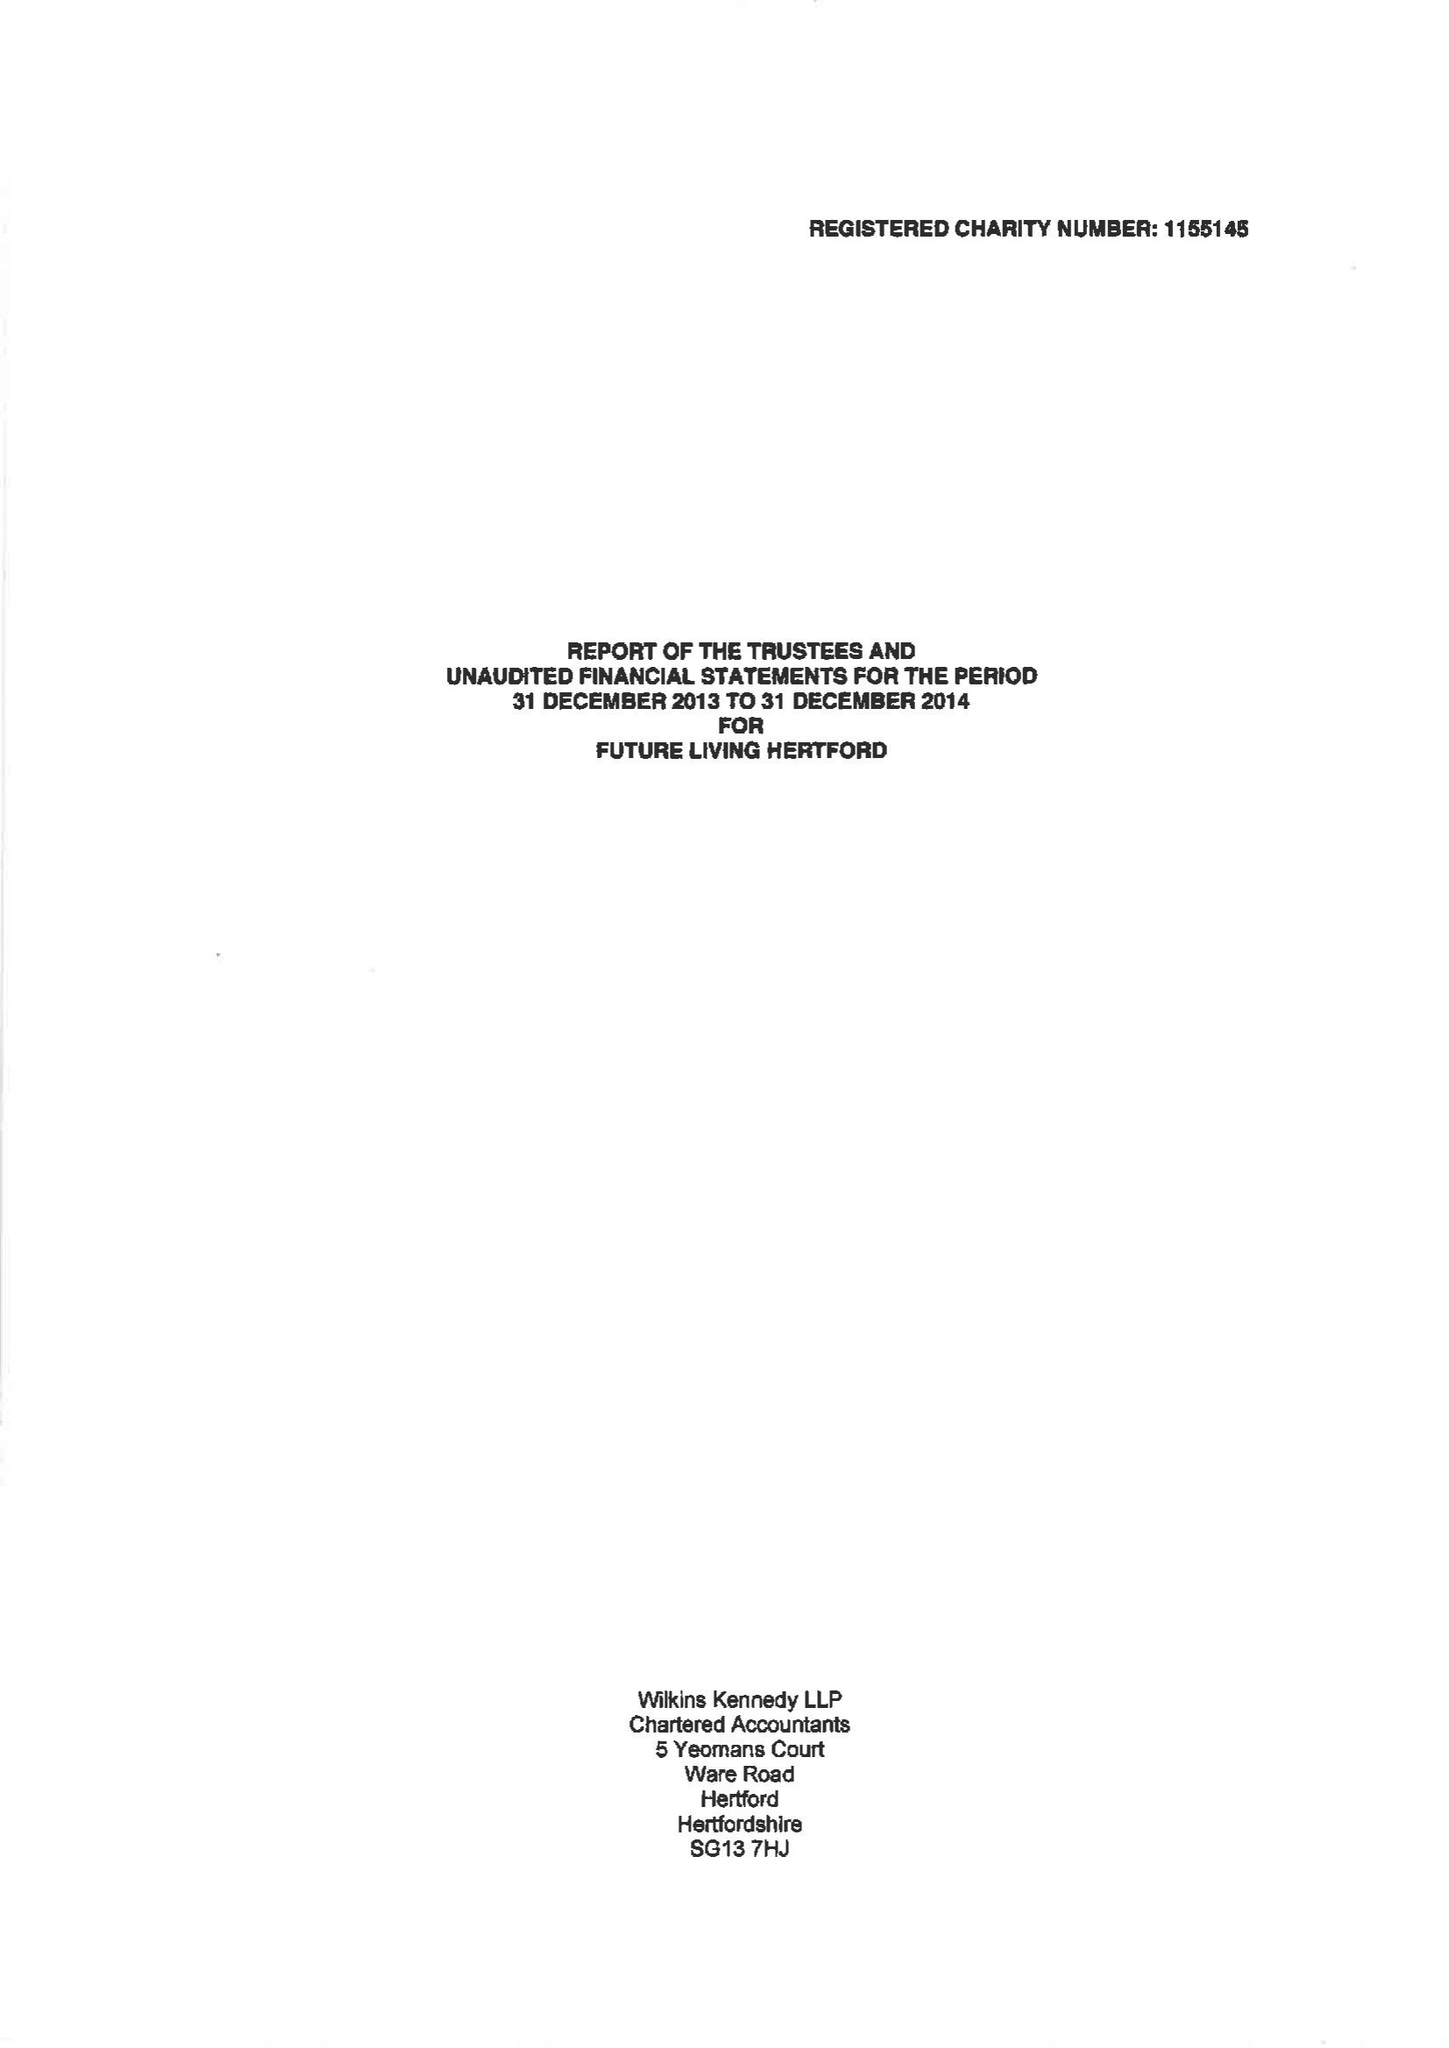What is the value for the address__post_town?
Answer the question using a single word or phrase. HERTFORD 